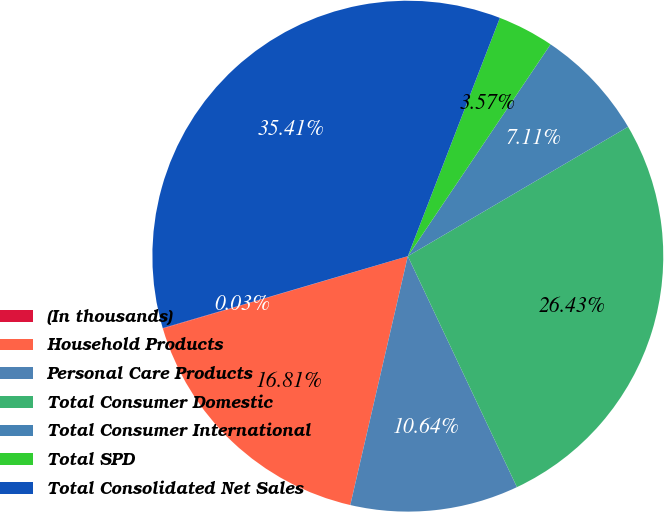Convert chart. <chart><loc_0><loc_0><loc_500><loc_500><pie_chart><fcel>(In thousands)<fcel>Household Products<fcel>Personal Care Products<fcel>Total Consumer Domestic<fcel>Total Consumer International<fcel>Total SPD<fcel>Total Consolidated Net Sales<nl><fcel>0.03%<fcel>16.81%<fcel>10.64%<fcel>26.43%<fcel>7.11%<fcel>3.57%<fcel>35.41%<nl></chart> 